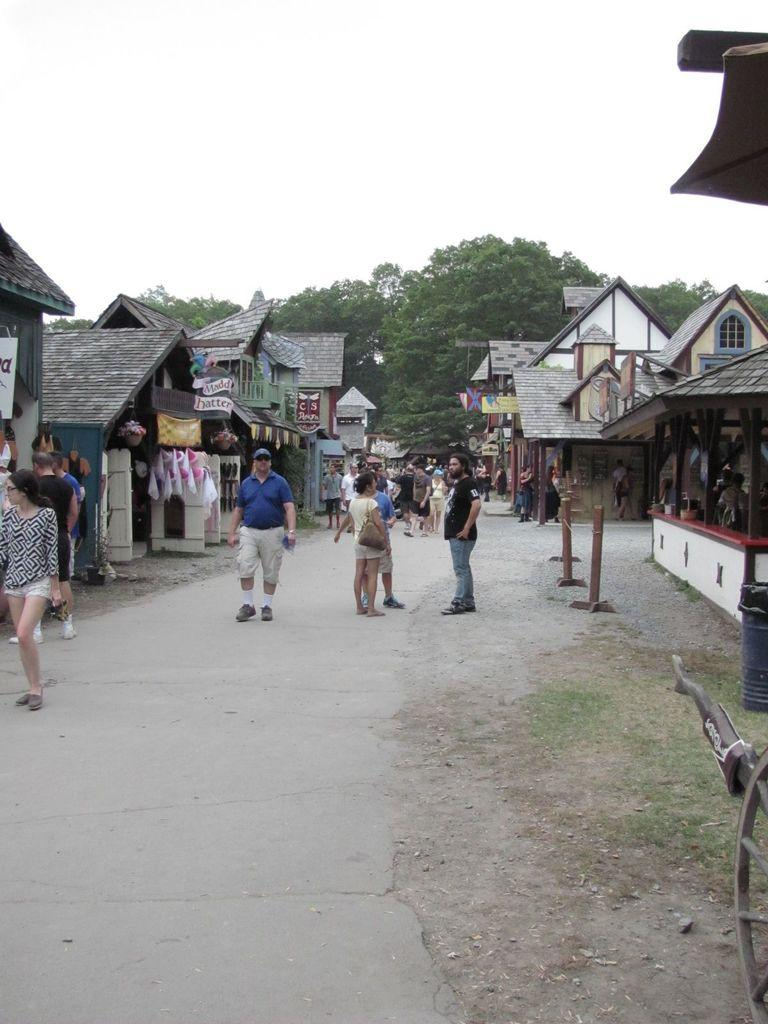What is the main feature of the image? There is a road in the image. What can be seen on the road? There are many people on the road. What surrounds the road? There are buildings on the sides of the road. What else is visible in the image besides the road and people? There are many items visible in the image. What can be seen in the background of the image? There are trees and the sky visible in the background of the image. What type of honey is being collected from the trees in the image? There are no trees with honey in the image; it only shows a road with people and buildings. What color is the orange that is being peeled by the people on the road? There is no orange present in the image; it only shows a road with people and buildings. 